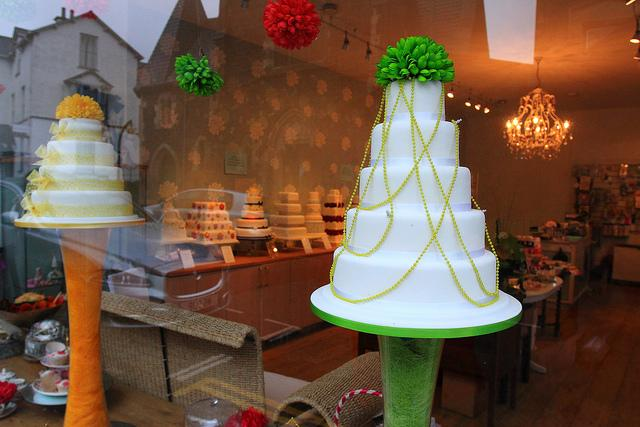What is inside of the large cake with green top and bottom? cake 